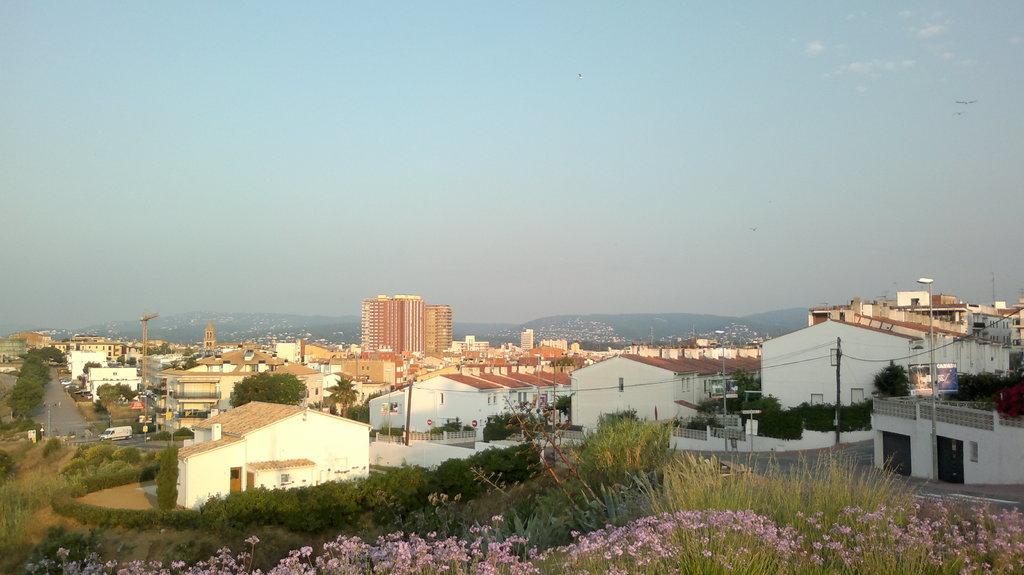Describe this image in one or two sentences. In the image we can see there are many buildings around. This is a road, electric pole, electric wires, grass, flower plants, trees, building crane, poster, mountain and a pale blue sky. We can see there are even birds flying in the sky. 